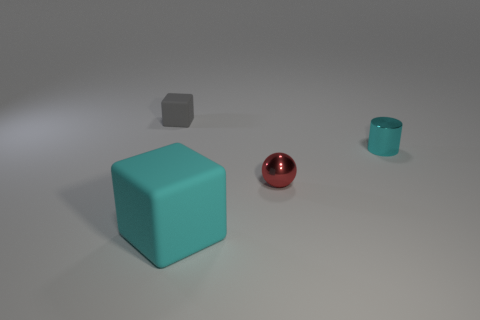Add 1 gray cubes. How many objects exist? 5 Subtract all gray blocks. How many blocks are left? 1 Subtract all cylinders. How many objects are left? 3 Subtract all red balls. How many cyan cubes are left? 1 Subtract all cyan matte things. Subtract all gray rubber objects. How many objects are left? 2 Add 4 metal cylinders. How many metal cylinders are left? 5 Add 2 cyan metal objects. How many cyan metal objects exist? 3 Subtract 0 purple cylinders. How many objects are left? 4 Subtract all gray balls. Subtract all gray cubes. How many balls are left? 1 